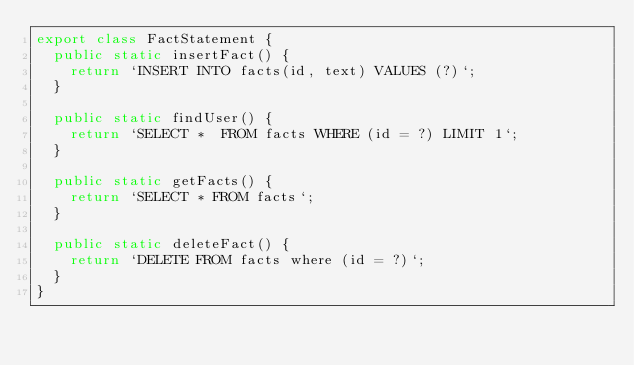Convert code to text. <code><loc_0><loc_0><loc_500><loc_500><_TypeScript_>export class FactStatement {
  public static insertFact() {
    return `INSERT INTO facts(id, text) VALUES (?)`;
  }

  public static findUser() {
    return `SELECT *  FROM facts WHERE (id = ?) LIMIT 1`;
  }

  public static getFacts() {
    return `SELECT * FROM facts`;
  }

  public static deleteFact() {
    return `DELETE FROM facts where (id = ?)`;
  }
}
</code> 